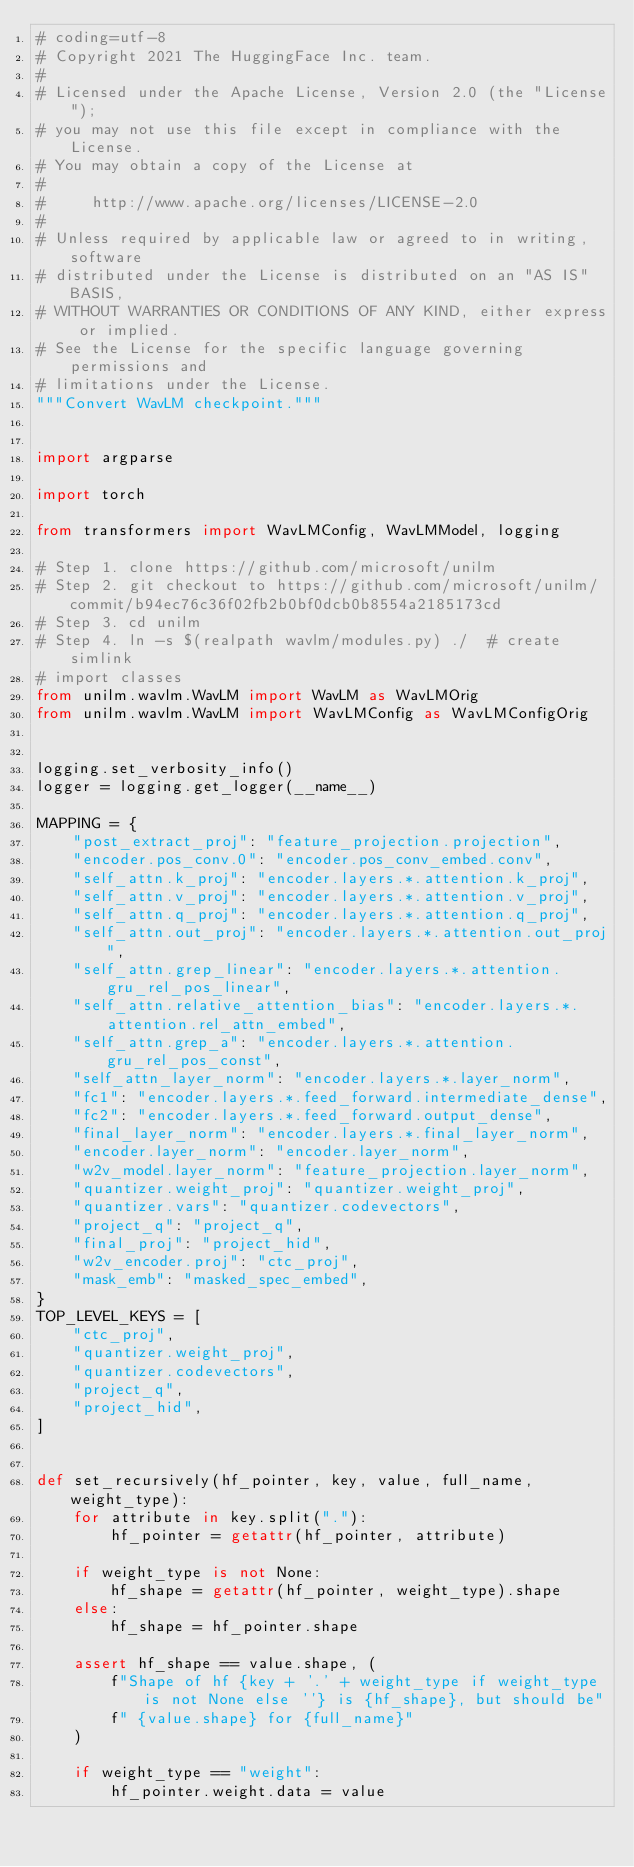<code> <loc_0><loc_0><loc_500><loc_500><_Python_># coding=utf-8
# Copyright 2021 The HuggingFace Inc. team.
#
# Licensed under the Apache License, Version 2.0 (the "License");
# you may not use this file except in compliance with the License.
# You may obtain a copy of the License at
#
#     http://www.apache.org/licenses/LICENSE-2.0
#
# Unless required by applicable law or agreed to in writing, software
# distributed under the License is distributed on an "AS IS" BASIS,
# WITHOUT WARRANTIES OR CONDITIONS OF ANY KIND, either express or implied.
# See the License for the specific language governing permissions and
# limitations under the License.
"""Convert WavLM checkpoint."""


import argparse

import torch

from transformers import WavLMConfig, WavLMModel, logging

# Step 1. clone https://github.com/microsoft/unilm
# Step 2. git checkout to https://github.com/microsoft/unilm/commit/b94ec76c36f02fb2b0bf0dcb0b8554a2185173cd
# Step 3. cd unilm
# Step 4. ln -s $(realpath wavlm/modules.py) ./  # create simlink
# import classes
from unilm.wavlm.WavLM import WavLM as WavLMOrig
from unilm.wavlm.WavLM import WavLMConfig as WavLMConfigOrig


logging.set_verbosity_info()
logger = logging.get_logger(__name__)

MAPPING = {
    "post_extract_proj": "feature_projection.projection",
    "encoder.pos_conv.0": "encoder.pos_conv_embed.conv",
    "self_attn.k_proj": "encoder.layers.*.attention.k_proj",
    "self_attn.v_proj": "encoder.layers.*.attention.v_proj",
    "self_attn.q_proj": "encoder.layers.*.attention.q_proj",
    "self_attn.out_proj": "encoder.layers.*.attention.out_proj",
    "self_attn.grep_linear": "encoder.layers.*.attention.gru_rel_pos_linear",
    "self_attn.relative_attention_bias": "encoder.layers.*.attention.rel_attn_embed",
    "self_attn.grep_a": "encoder.layers.*.attention.gru_rel_pos_const",
    "self_attn_layer_norm": "encoder.layers.*.layer_norm",
    "fc1": "encoder.layers.*.feed_forward.intermediate_dense",
    "fc2": "encoder.layers.*.feed_forward.output_dense",
    "final_layer_norm": "encoder.layers.*.final_layer_norm",
    "encoder.layer_norm": "encoder.layer_norm",
    "w2v_model.layer_norm": "feature_projection.layer_norm",
    "quantizer.weight_proj": "quantizer.weight_proj",
    "quantizer.vars": "quantizer.codevectors",
    "project_q": "project_q",
    "final_proj": "project_hid",
    "w2v_encoder.proj": "ctc_proj",
    "mask_emb": "masked_spec_embed",
}
TOP_LEVEL_KEYS = [
    "ctc_proj",
    "quantizer.weight_proj",
    "quantizer.codevectors",
    "project_q",
    "project_hid",
]


def set_recursively(hf_pointer, key, value, full_name, weight_type):
    for attribute in key.split("."):
        hf_pointer = getattr(hf_pointer, attribute)

    if weight_type is not None:
        hf_shape = getattr(hf_pointer, weight_type).shape
    else:
        hf_shape = hf_pointer.shape

    assert hf_shape == value.shape, (
        f"Shape of hf {key + '.' + weight_type if weight_type is not None else ''} is {hf_shape}, but should be"
        f" {value.shape} for {full_name}"
    )

    if weight_type == "weight":
        hf_pointer.weight.data = value</code> 